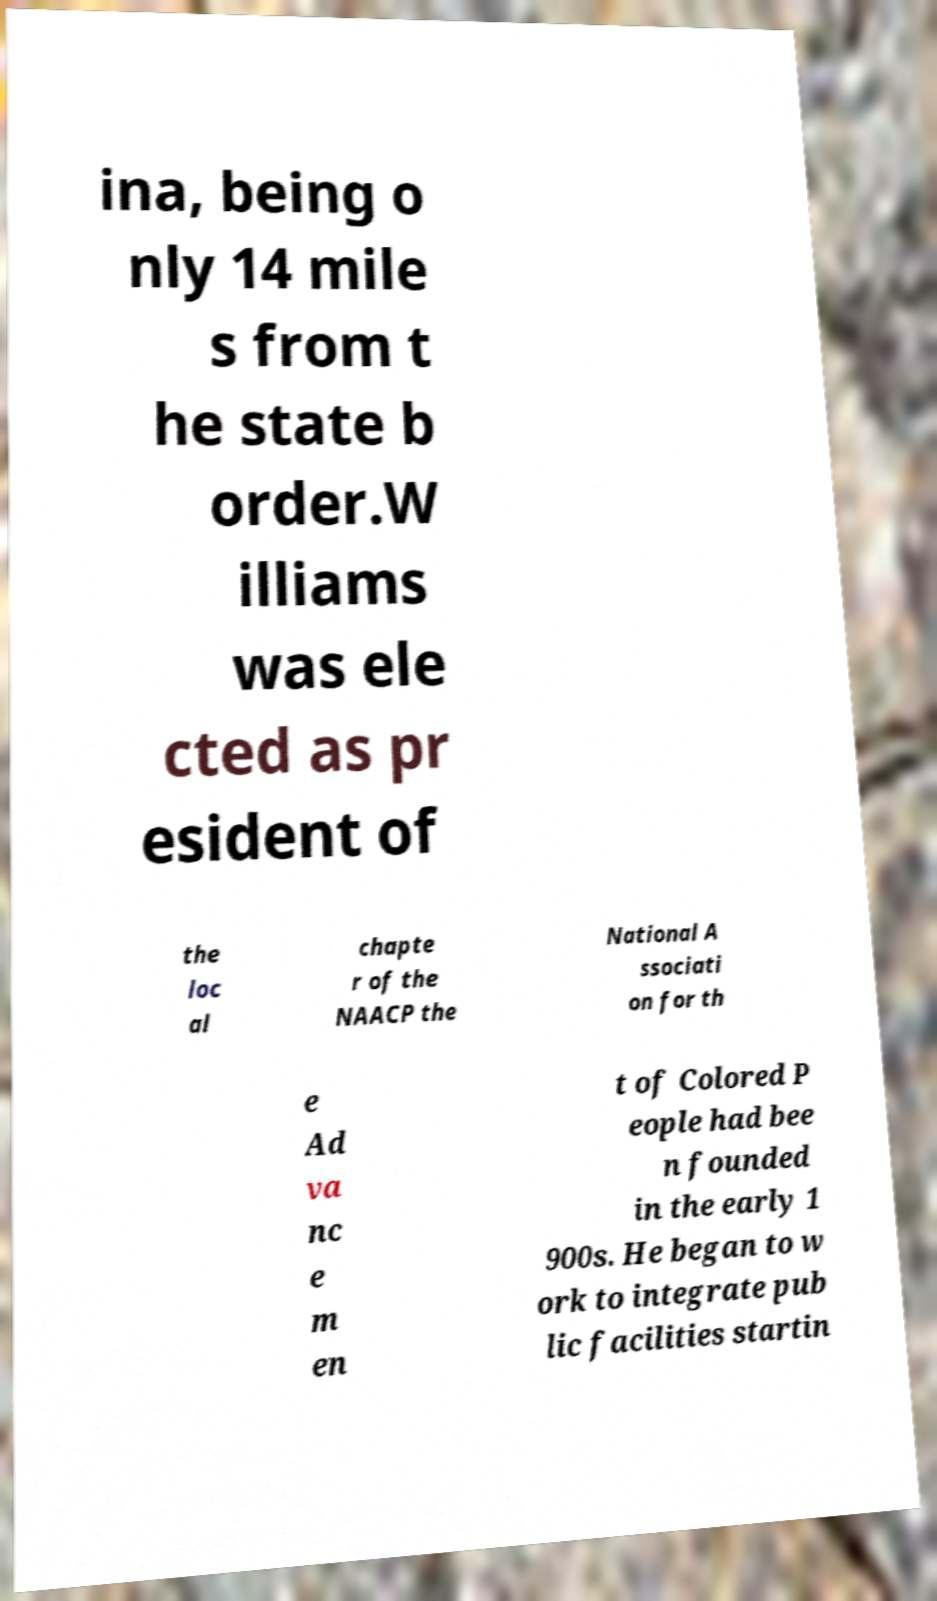There's text embedded in this image that I need extracted. Can you transcribe it verbatim? ina, being o nly 14 mile s from t he state b order.W illiams was ele cted as pr esident of the loc al chapte r of the NAACP the National A ssociati on for th e Ad va nc e m en t of Colored P eople had bee n founded in the early 1 900s. He began to w ork to integrate pub lic facilities startin 